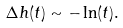<formula> <loc_0><loc_0><loc_500><loc_500>\Delta h ( t ) \sim - \ln ( t ) .</formula> 